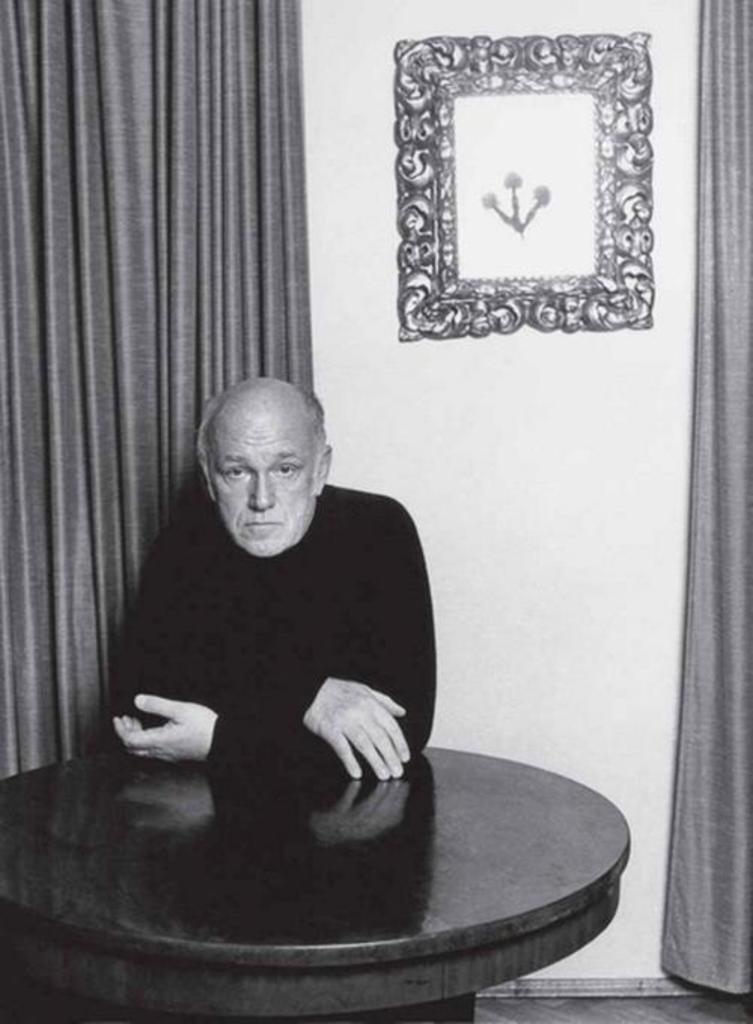Who is present in the image? There is a man in the image. What is the man doing in the image? The man is sitting on a chair. What other objects can be seen in the image? There is a table, a curtain, a wall, and a wall frame in the image. What type of road can be seen through the hole in the wall frame? There is no hole in the wall frame, nor is there a road visible in the image. 